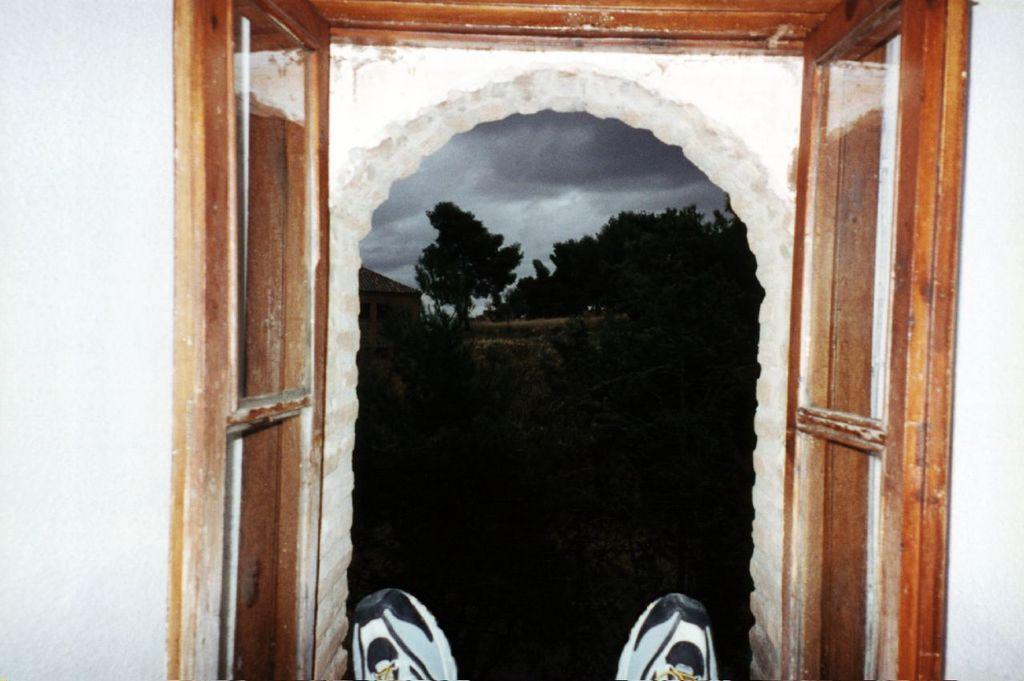How would you summarize this image in a sentence or two? There is a window. Near to the window we can see shoes. In the background there are trees, building and sky with clouds. 